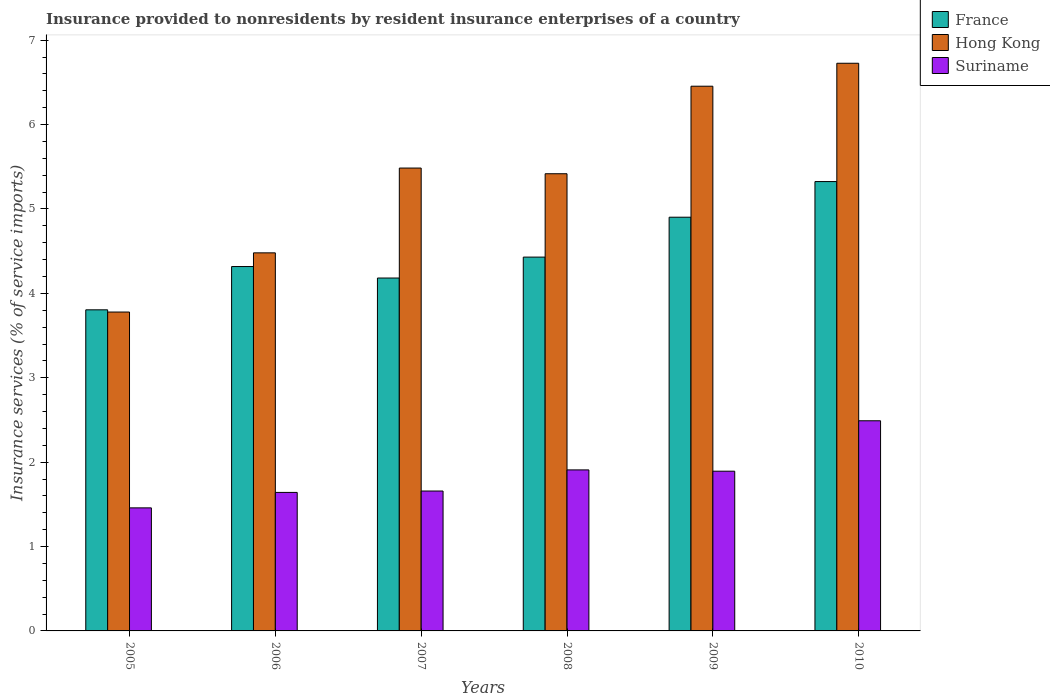How many groups of bars are there?
Ensure brevity in your answer.  6. Are the number of bars per tick equal to the number of legend labels?
Ensure brevity in your answer.  Yes. What is the label of the 2nd group of bars from the left?
Your response must be concise. 2006. In how many cases, is the number of bars for a given year not equal to the number of legend labels?
Offer a very short reply. 0. What is the insurance provided to nonresidents in Suriname in 2009?
Keep it short and to the point. 1.89. Across all years, what is the maximum insurance provided to nonresidents in Suriname?
Provide a succinct answer. 2.49. Across all years, what is the minimum insurance provided to nonresidents in France?
Keep it short and to the point. 3.81. In which year was the insurance provided to nonresidents in Hong Kong minimum?
Ensure brevity in your answer.  2005. What is the total insurance provided to nonresidents in Suriname in the graph?
Your answer should be very brief. 11.05. What is the difference between the insurance provided to nonresidents in Hong Kong in 2005 and that in 2010?
Your answer should be compact. -2.95. What is the difference between the insurance provided to nonresidents in Hong Kong in 2008 and the insurance provided to nonresidents in France in 2009?
Keep it short and to the point. 0.52. What is the average insurance provided to nonresidents in Hong Kong per year?
Your answer should be compact. 5.39. In the year 2006, what is the difference between the insurance provided to nonresidents in Suriname and insurance provided to nonresidents in France?
Your answer should be compact. -2.68. What is the ratio of the insurance provided to nonresidents in Suriname in 2005 to that in 2009?
Give a very brief answer. 0.77. What is the difference between the highest and the second highest insurance provided to nonresidents in France?
Your answer should be very brief. 0.42. What is the difference between the highest and the lowest insurance provided to nonresidents in Hong Kong?
Give a very brief answer. 2.95. Is the sum of the insurance provided to nonresidents in Suriname in 2006 and 2010 greater than the maximum insurance provided to nonresidents in France across all years?
Your answer should be compact. No. What does the 3rd bar from the left in 2007 represents?
Keep it short and to the point. Suriname. What does the 2nd bar from the right in 2006 represents?
Keep it short and to the point. Hong Kong. Is it the case that in every year, the sum of the insurance provided to nonresidents in France and insurance provided to nonresidents in Hong Kong is greater than the insurance provided to nonresidents in Suriname?
Your answer should be compact. Yes. Where does the legend appear in the graph?
Provide a succinct answer. Top right. What is the title of the graph?
Offer a terse response. Insurance provided to nonresidents by resident insurance enterprises of a country. Does "Tanzania" appear as one of the legend labels in the graph?
Offer a very short reply. No. What is the label or title of the X-axis?
Give a very brief answer. Years. What is the label or title of the Y-axis?
Keep it short and to the point. Insurance services (% of service imports). What is the Insurance services (% of service imports) in France in 2005?
Offer a very short reply. 3.81. What is the Insurance services (% of service imports) in Hong Kong in 2005?
Make the answer very short. 3.78. What is the Insurance services (% of service imports) of Suriname in 2005?
Give a very brief answer. 1.46. What is the Insurance services (% of service imports) of France in 2006?
Make the answer very short. 4.32. What is the Insurance services (% of service imports) of Hong Kong in 2006?
Provide a succinct answer. 4.48. What is the Insurance services (% of service imports) of Suriname in 2006?
Offer a terse response. 1.64. What is the Insurance services (% of service imports) of France in 2007?
Your response must be concise. 4.18. What is the Insurance services (% of service imports) of Hong Kong in 2007?
Provide a succinct answer. 5.49. What is the Insurance services (% of service imports) of Suriname in 2007?
Your answer should be compact. 1.66. What is the Insurance services (% of service imports) in France in 2008?
Your answer should be compact. 4.43. What is the Insurance services (% of service imports) of Hong Kong in 2008?
Make the answer very short. 5.42. What is the Insurance services (% of service imports) of Suriname in 2008?
Your answer should be compact. 1.91. What is the Insurance services (% of service imports) in France in 2009?
Your answer should be compact. 4.9. What is the Insurance services (% of service imports) of Hong Kong in 2009?
Provide a short and direct response. 6.45. What is the Insurance services (% of service imports) in Suriname in 2009?
Your response must be concise. 1.89. What is the Insurance services (% of service imports) of France in 2010?
Offer a terse response. 5.32. What is the Insurance services (% of service imports) of Hong Kong in 2010?
Provide a succinct answer. 6.73. What is the Insurance services (% of service imports) in Suriname in 2010?
Provide a succinct answer. 2.49. Across all years, what is the maximum Insurance services (% of service imports) of France?
Provide a succinct answer. 5.32. Across all years, what is the maximum Insurance services (% of service imports) of Hong Kong?
Offer a very short reply. 6.73. Across all years, what is the maximum Insurance services (% of service imports) of Suriname?
Make the answer very short. 2.49. Across all years, what is the minimum Insurance services (% of service imports) in France?
Ensure brevity in your answer.  3.81. Across all years, what is the minimum Insurance services (% of service imports) in Hong Kong?
Ensure brevity in your answer.  3.78. Across all years, what is the minimum Insurance services (% of service imports) in Suriname?
Your answer should be very brief. 1.46. What is the total Insurance services (% of service imports) in France in the graph?
Your answer should be very brief. 26.96. What is the total Insurance services (% of service imports) in Hong Kong in the graph?
Offer a terse response. 32.34. What is the total Insurance services (% of service imports) in Suriname in the graph?
Provide a succinct answer. 11.05. What is the difference between the Insurance services (% of service imports) in France in 2005 and that in 2006?
Make the answer very short. -0.51. What is the difference between the Insurance services (% of service imports) in Hong Kong in 2005 and that in 2006?
Provide a short and direct response. -0.7. What is the difference between the Insurance services (% of service imports) of Suriname in 2005 and that in 2006?
Your response must be concise. -0.18. What is the difference between the Insurance services (% of service imports) in France in 2005 and that in 2007?
Give a very brief answer. -0.38. What is the difference between the Insurance services (% of service imports) in Hong Kong in 2005 and that in 2007?
Keep it short and to the point. -1.71. What is the difference between the Insurance services (% of service imports) of Suriname in 2005 and that in 2007?
Make the answer very short. -0.2. What is the difference between the Insurance services (% of service imports) in France in 2005 and that in 2008?
Your answer should be very brief. -0.62. What is the difference between the Insurance services (% of service imports) of Hong Kong in 2005 and that in 2008?
Provide a succinct answer. -1.64. What is the difference between the Insurance services (% of service imports) of Suriname in 2005 and that in 2008?
Keep it short and to the point. -0.45. What is the difference between the Insurance services (% of service imports) of France in 2005 and that in 2009?
Your response must be concise. -1.1. What is the difference between the Insurance services (% of service imports) of Hong Kong in 2005 and that in 2009?
Your response must be concise. -2.68. What is the difference between the Insurance services (% of service imports) in Suriname in 2005 and that in 2009?
Give a very brief answer. -0.43. What is the difference between the Insurance services (% of service imports) in France in 2005 and that in 2010?
Offer a very short reply. -1.52. What is the difference between the Insurance services (% of service imports) of Hong Kong in 2005 and that in 2010?
Your answer should be compact. -2.95. What is the difference between the Insurance services (% of service imports) in Suriname in 2005 and that in 2010?
Your answer should be very brief. -1.03. What is the difference between the Insurance services (% of service imports) of France in 2006 and that in 2007?
Your answer should be compact. 0.14. What is the difference between the Insurance services (% of service imports) of Hong Kong in 2006 and that in 2007?
Your response must be concise. -1. What is the difference between the Insurance services (% of service imports) in Suriname in 2006 and that in 2007?
Ensure brevity in your answer.  -0.02. What is the difference between the Insurance services (% of service imports) of France in 2006 and that in 2008?
Make the answer very short. -0.11. What is the difference between the Insurance services (% of service imports) of Hong Kong in 2006 and that in 2008?
Keep it short and to the point. -0.94. What is the difference between the Insurance services (% of service imports) in Suriname in 2006 and that in 2008?
Offer a terse response. -0.27. What is the difference between the Insurance services (% of service imports) in France in 2006 and that in 2009?
Make the answer very short. -0.58. What is the difference between the Insurance services (% of service imports) of Hong Kong in 2006 and that in 2009?
Your answer should be compact. -1.97. What is the difference between the Insurance services (% of service imports) in Suriname in 2006 and that in 2009?
Offer a very short reply. -0.25. What is the difference between the Insurance services (% of service imports) of France in 2006 and that in 2010?
Keep it short and to the point. -1.01. What is the difference between the Insurance services (% of service imports) of Hong Kong in 2006 and that in 2010?
Your response must be concise. -2.25. What is the difference between the Insurance services (% of service imports) of Suriname in 2006 and that in 2010?
Offer a very short reply. -0.85. What is the difference between the Insurance services (% of service imports) of France in 2007 and that in 2008?
Provide a short and direct response. -0.25. What is the difference between the Insurance services (% of service imports) in Hong Kong in 2007 and that in 2008?
Provide a short and direct response. 0.07. What is the difference between the Insurance services (% of service imports) of Suriname in 2007 and that in 2008?
Provide a succinct answer. -0.25. What is the difference between the Insurance services (% of service imports) of France in 2007 and that in 2009?
Provide a succinct answer. -0.72. What is the difference between the Insurance services (% of service imports) in Hong Kong in 2007 and that in 2009?
Your response must be concise. -0.97. What is the difference between the Insurance services (% of service imports) of Suriname in 2007 and that in 2009?
Provide a succinct answer. -0.23. What is the difference between the Insurance services (% of service imports) in France in 2007 and that in 2010?
Your answer should be compact. -1.14. What is the difference between the Insurance services (% of service imports) in Hong Kong in 2007 and that in 2010?
Provide a short and direct response. -1.24. What is the difference between the Insurance services (% of service imports) in Suriname in 2007 and that in 2010?
Provide a short and direct response. -0.83. What is the difference between the Insurance services (% of service imports) of France in 2008 and that in 2009?
Your response must be concise. -0.47. What is the difference between the Insurance services (% of service imports) in Hong Kong in 2008 and that in 2009?
Your answer should be very brief. -1.04. What is the difference between the Insurance services (% of service imports) in Suriname in 2008 and that in 2009?
Provide a short and direct response. 0.02. What is the difference between the Insurance services (% of service imports) of France in 2008 and that in 2010?
Ensure brevity in your answer.  -0.9. What is the difference between the Insurance services (% of service imports) of Hong Kong in 2008 and that in 2010?
Provide a succinct answer. -1.31. What is the difference between the Insurance services (% of service imports) in Suriname in 2008 and that in 2010?
Make the answer very short. -0.58. What is the difference between the Insurance services (% of service imports) of France in 2009 and that in 2010?
Offer a terse response. -0.42. What is the difference between the Insurance services (% of service imports) in Hong Kong in 2009 and that in 2010?
Offer a very short reply. -0.27. What is the difference between the Insurance services (% of service imports) in Suriname in 2009 and that in 2010?
Offer a terse response. -0.6. What is the difference between the Insurance services (% of service imports) in France in 2005 and the Insurance services (% of service imports) in Hong Kong in 2006?
Give a very brief answer. -0.68. What is the difference between the Insurance services (% of service imports) in France in 2005 and the Insurance services (% of service imports) in Suriname in 2006?
Make the answer very short. 2.16. What is the difference between the Insurance services (% of service imports) in Hong Kong in 2005 and the Insurance services (% of service imports) in Suriname in 2006?
Offer a terse response. 2.14. What is the difference between the Insurance services (% of service imports) of France in 2005 and the Insurance services (% of service imports) of Hong Kong in 2007?
Give a very brief answer. -1.68. What is the difference between the Insurance services (% of service imports) in France in 2005 and the Insurance services (% of service imports) in Suriname in 2007?
Provide a short and direct response. 2.15. What is the difference between the Insurance services (% of service imports) of Hong Kong in 2005 and the Insurance services (% of service imports) of Suriname in 2007?
Your response must be concise. 2.12. What is the difference between the Insurance services (% of service imports) of France in 2005 and the Insurance services (% of service imports) of Hong Kong in 2008?
Provide a short and direct response. -1.61. What is the difference between the Insurance services (% of service imports) of France in 2005 and the Insurance services (% of service imports) of Suriname in 2008?
Offer a terse response. 1.9. What is the difference between the Insurance services (% of service imports) in Hong Kong in 2005 and the Insurance services (% of service imports) in Suriname in 2008?
Your response must be concise. 1.87. What is the difference between the Insurance services (% of service imports) of France in 2005 and the Insurance services (% of service imports) of Hong Kong in 2009?
Your response must be concise. -2.65. What is the difference between the Insurance services (% of service imports) of France in 2005 and the Insurance services (% of service imports) of Suriname in 2009?
Ensure brevity in your answer.  1.91. What is the difference between the Insurance services (% of service imports) in Hong Kong in 2005 and the Insurance services (% of service imports) in Suriname in 2009?
Make the answer very short. 1.89. What is the difference between the Insurance services (% of service imports) in France in 2005 and the Insurance services (% of service imports) in Hong Kong in 2010?
Ensure brevity in your answer.  -2.92. What is the difference between the Insurance services (% of service imports) of France in 2005 and the Insurance services (% of service imports) of Suriname in 2010?
Your answer should be very brief. 1.31. What is the difference between the Insurance services (% of service imports) of Hong Kong in 2005 and the Insurance services (% of service imports) of Suriname in 2010?
Offer a very short reply. 1.29. What is the difference between the Insurance services (% of service imports) in France in 2006 and the Insurance services (% of service imports) in Hong Kong in 2007?
Provide a short and direct response. -1.17. What is the difference between the Insurance services (% of service imports) in France in 2006 and the Insurance services (% of service imports) in Suriname in 2007?
Provide a short and direct response. 2.66. What is the difference between the Insurance services (% of service imports) in Hong Kong in 2006 and the Insurance services (% of service imports) in Suriname in 2007?
Your response must be concise. 2.82. What is the difference between the Insurance services (% of service imports) of France in 2006 and the Insurance services (% of service imports) of Hong Kong in 2008?
Provide a short and direct response. -1.1. What is the difference between the Insurance services (% of service imports) of France in 2006 and the Insurance services (% of service imports) of Suriname in 2008?
Make the answer very short. 2.41. What is the difference between the Insurance services (% of service imports) of Hong Kong in 2006 and the Insurance services (% of service imports) of Suriname in 2008?
Offer a terse response. 2.57. What is the difference between the Insurance services (% of service imports) of France in 2006 and the Insurance services (% of service imports) of Hong Kong in 2009?
Your answer should be very brief. -2.14. What is the difference between the Insurance services (% of service imports) in France in 2006 and the Insurance services (% of service imports) in Suriname in 2009?
Provide a succinct answer. 2.43. What is the difference between the Insurance services (% of service imports) in Hong Kong in 2006 and the Insurance services (% of service imports) in Suriname in 2009?
Give a very brief answer. 2.59. What is the difference between the Insurance services (% of service imports) in France in 2006 and the Insurance services (% of service imports) in Hong Kong in 2010?
Ensure brevity in your answer.  -2.41. What is the difference between the Insurance services (% of service imports) of France in 2006 and the Insurance services (% of service imports) of Suriname in 2010?
Ensure brevity in your answer.  1.83. What is the difference between the Insurance services (% of service imports) of Hong Kong in 2006 and the Insurance services (% of service imports) of Suriname in 2010?
Give a very brief answer. 1.99. What is the difference between the Insurance services (% of service imports) of France in 2007 and the Insurance services (% of service imports) of Hong Kong in 2008?
Your answer should be very brief. -1.24. What is the difference between the Insurance services (% of service imports) of France in 2007 and the Insurance services (% of service imports) of Suriname in 2008?
Your answer should be very brief. 2.27. What is the difference between the Insurance services (% of service imports) in Hong Kong in 2007 and the Insurance services (% of service imports) in Suriname in 2008?
Provide a succinct answer. 3.58. What is the difference between the Insurance services (% of service imports) in France in 2007 and the Insurance services (% of service imports) in Hong Kong in 2009?
Make the answer very short. -2.27. What is the difference between the Insurance services (% of service imports) of France in 2007 and the Insurance services (% of service imports) of Suriname in 2009?
Ensure brevity in your answer.  2.29. What is the difference between the Insurance services (% of service imports) of Hong Kong in 2007 and the Insurance services (% of service imports) of Suriname in 2009?
Make the answer very short. 3.59. What is the difference between the Insurance services (% of service imports) in France in 2007 and the Insurance services (% of service imports) in Hong Kong in 2010?
Your answer should be compact. -2.55. What is the difference between the Insurance services (% of service imports) in France in 2007 and the Insurance services (% of service imports) in Suriname in 2010?
Your answer should be compact. 1.69. What is the difference between the Insurance services (% of service imports) in Hong Kong in 2007 and the Insurance services (% of service imports) in Suriname in 2010?
Provide a succinct answer. 2.99. What is the difference between the Insurance services (% of service imports) in France in 2008 and the Insurance services (% of service imports) in Hong Kong in 2009?
Your answer should be very brief. -2.03. What is the difference between the Insurance services (% of service imports) in France in 2008 and the Insurance services (% of service imports) in Suriname in 2009?
Your answer should be compact. 2.54. What is the difference between the Insurance services (% of service imports) of Hong Kong in 2008 and the Insurance services (% of service imports) of Suriname in 2009?
Make the answer very short. 3.52. What is the difference between the Insurance services (% of service imports) of France in 2008 and the Insurance services (% of service imports) of Hong Kong in 2010?
Give a very brief answer. -2.3. What is the difference between the Insurance services (% of service imports) of France in 2008 and the Insurance services (% of service imports) of Suriname in 2010?
Provide a succinct answer. 1.94. What is the difference between the Insurance services (% of service imports) of Hong Kong in 2008 and the Insurance services (% of service imports) of Suriname in 2010?
Provide a short and direct response. 2.93. What is the difference between the Insurance services (% of service imports) in France in 2009 and the Insurance services (% of service imports) in Hong Kong in 2010?
Offer a terse response. -1.82. What is the difference between the Insurance services (% of service imports) in France in 2009 and the Insurance services (% of service imports) in Suriname in 2010?
Offer a very short reply. 2.41. What is the difference between the Insurance services (% of service imports) in Hong Kong in 2009 and the Insurance services (% of service imports) in Suriname in 2010?
Keep it short and to the point. 3.96. What is the average Insurance services (% of service imports) in France per year?
Give a very brief answer. 4.49. What is the average Insurance services (% of service imports) of Hong Kong per year?
Your answer should be compact. 5.39. What is the average Insurance services (% of service imports) of Suriname per year?
Your response must be concise. 1.84. In the year 2005, what is the difference between the Insurance services (% of service imports) in France and Insurance services (% of service imports) in Hong Kong?
Ensure brevity in your answer.  0.03. In the year 2005, what is the difference between the Insurance services (% of service imports) in France and Insurance services (% of service imports) in Suriname?
Your answer should be very brief. 2.35. In the year 2005, what is the difference between the Insurance services (% of service imports) of Hong Kong and Insurance services (% of service imports) of Suriname?
Your answer should be very brief. 2.32. In the year 2006, what is the difference between the Insurance services (% of service imports) of France and Insurance services (% of service imports) of Hong Kong?
Give a very brief answer. -0.16. In the year 2006, what is the difference between the Insurance services (% of service imports) of France and Insurance services (% of service imports) of Suriname?
Provide a succinct answer. 2.68. In the year 2006, what is the difference between the Insurance services (% of service imports) of Hong Kong and Insurance services (% of service imports) of Suriname?
Your response must be concise. 2.84. In the year 2007, what is the difference between the Insurance services (% of service imports) in France and Insurance services (% of service imports) in Hong Kong?
Your answer should be very brief. -1.3. In the year 2007, what is the difference between the Insurance services (% of service imports) of France and Insurance services (% of service imports) of Suriname?
Your answer should be compact. 2.52. In the year 2007, what is the difference between the Insurance services (% of service imports) of Hong Kong and Insurance services (% of service imports) of Suriname?
Ensure brevity in your answer.  3.83. In the year 2008, what is the difference between the Insurance services (% of service imports) of France and Insurance services (% of service imports) of Hong Kong?
Keep it short and to the point. -0.99. In the year 2008, what is the difference between the Insurance services (% of service imports) of France and Insurance services (% of service imports) of Suriname?
Provide a short and direct response. 2.52. In the year 2008, what is the difference between the Insurance services (% of service imports) in Hong Kong and Insurance services (% of service imports) in Suriname?
Provide a succinct answer. 3.51. In the year 2009, what is the difference between the Insurance services (% of service imports) of France and Insurance services (% of service imports) of Hong Kong?
Provide a short and direct response. -1.55. In the year 2009, what is the difference between the Insurance services (% of service imports) in France and Insurance services (% of service imports) in Suriname?
Ensure brevity in your answer.  3.01. In the year 2009, what is the difference between the Insurance services (% of service imports) of Hong Kong and Insurance services (% of service imports) of Suriname?
Provide a succinct answer. 4.56. In the year 2010, what is the difference between the Insurance services (% of service imports) in France and Insurance services (% of service imports) in Hong Kong?
Ensure brevity in your answer.  -1.4. In the year 2010, what is the difference between the Insurance services (% of service imports) in France and Insurance services (% of service imports) in Suriname?
Your answer should be very brief. 2.83. In the year 2010, what is the difference between the Insurance services (% of service imports) in Hong Kong and Insurance services (% of service imports) in Suriname?
Make the answer very short. 4.24. What is the ratio of the Insurance services (% of service imports) in France in 2005 to that in 2006?
Make the answer very short. 0.88. What is the ratio of the Insurance services (% of service imports) of Hong Kong in 2005 to that in 2006?
Your response must be concise. 0.84. What is the ratio of the Insurance services (% of service imports) of Suriname in 2005 to that in 2006?
Your response must be concise. 0.89. What is the ratio of the Insurance services (% of service imports) in France in 2005 to that in 2007?
Offer a terse response. 0.91. What is the ratio of the Insurance services (% of service imports) of Hong Kong in 2005 to that in 2007?
Offer a terse response. 0.69. What is the ratio of the Insurance services (% of service imports) in Suriname in 2005 to that in 2007?
Your answer should be very brief. 0.88. What is the ratio of the Insurance services (% of service imports) of France in 2005 to that in 2008?
Ensure brevity in your answer.  0.86. What is the ratio of the Insurance services (% of service imports) of Hong Kong in 2005 to that in 2008?
Provide a succinct answer. 0.7. What is the ratio of the Insurance services (% of service imports) of Suriname in 2005 to that in 2008?
Keep it short and to the point. 0.76. What is the ratio of the Insurance services (% of service imports) of France in 2005 to that in 2009?
Ensure brevity in your answer.  0.78. What is the ratio of the Insurance services (% of service imports) in Hong Kong in 2005 to that in 2009?
Provide a short and direct response. 0.59. What is the ratio of the Insurance services (% of service imports) of Suriname in 2005 to that in 2009?
Make the answer very short. 0.77. What is the ratio of the Insurance services (% of service imports) of France in 2005 to that in 2010?
Your response must be concise. 0.71. What is the ratio of the Insurance services (% of service imports) in Hong Kong in 2005 to that in 2010?
Your response must be concise. 0.56. What is the ratio of the Insurance services (% of service imports) of Suriname in 2005 to that in 2010?
Offer a terse response. 0.59. What is the ratio of the Insurance services (% of service imports) of France in 2006 to that in 2007?
Offer a terse response. 1.03. What is the ratio of the Insurance services (% of service imports) in Hong Kong in 2006 to that in 2007?
Your response must be concise. 0.82. What is the ratio of the Insurance services (% of service imports) in Suriname in 2006 to that in 2007?
Provide a succinct answer. 0.99. What is the ratio of the Insurance services (% of service imports) in France in 2006 to that in 2008?
Offer a terse response. 0.97. What is the ratio of the Insurance services (% of service imports) of Hong Kong in 2006 to that in 2008?
Keep it short and to the point. 0.83. What is the ratio of the Insurance services (% of service imports) of Suriname in 2006 to that in 2008?
Offer a terse response. 0.86. What is the ratio of the Insurance services (% of service imports) in France in 2006 to that in 2009?
Offer a terse response. 0.88. What is the ratio of the Insurance services (% of service imports) of Hong Kong in 2006 to that in 2009?
Give a very brief answer. 0.69. What is the ratio of the Insurance services (% of service imports) in Suriname in 2006 to that in 2009?
Your answer should be very brief. 0.87. What is the ratio of the Insurance services (% of service imports) in France in 2006 to that in 2010?
Your answer should be very brief. 0.81. What is the ratio of the Insurance services (% of service imports) in Hong Kong in 2006 to that in 2010?
Make the answer very short. 0.67. What is the ratio of the Insurance services (% of service imports) of Suriname in 2006 to that in 2010?
Make the answer very short. 0.66. What is the ratio of the Insurance services (% of service imports) of France in 2007 to that in 2008?
Offer a terse response. 0.94. What is the ratio of the Insurance services (% of service imports) of Hong Kong in 2007 to that in 2008?
Offer a terse response. 1.01. What is the ratio of the Insurance services (% of service imports) in Suriname in 2007 to that in 2008?
Your response must be concise. 0.87. What is the ratio of the Insurance services (% of service imports) of France in 2007 to that in 2009?
Keep it short and to the point. 0.85. What is the ratio of the Insurance services (% of service imports) in Hong Kong in 2007 to that in 2009?
Make the answer very short. 0.85. What is the ratio of the Insurance services (% of service imports) in Suriname in 2007 to that in 2009?
Provide a short and direct response. 0.88. What is the ratio of the Insurance services (% of service imports) in France in 2007 to that in 2010?
Provide a succinct answer. 0.79. What is the ratio of the Insurance services (% of service imports) of Hong Kong in 2007 to that in 2010?
Your answer should be very brief. 0.82. What is the ratio of the Insurance services (% of service imports) in Suriname in 2007 to that in 2010?
Give a very brief answer. 0.67. What is the ratio of the Insurance services (% of service imports) in France in 2008 to that in 2009?
Give a very brief answer. 0.9. What is the ratio of the Insurance services (% of service imports) of Hong Kong in 2008 to that in 2009?
Provide a short and direct response. 0.84. What is the ratio of the Insurance services (% of service imports) in France in 2008 to that in 2010?
Your answer should be very brief. 0.83. What is the ratio of the Insurance services (% of service imports) of Hong Kong in 2008 to that in 2010?
Ensure brevity in your answer.  0.81. What is the ratio of the Insurance services (% of service imports) of Suriname in 2008 to that in 2010?
Your response must be concise. 0.77. What is the ratio of the Insurance services (% of service imports) in France in 2009 to that in 2010?
Provide a succinct answer. 0.92. What is the ratio of the Insurance services (% of service imports) of Hong Kong in 2009 to that in 2010?
Keep it short and to the point. 0.96. What is the ratio of the Insurance services (% of service imports) of Suriname in 2009 to that in 2010?
Your response must be concise. 0.76. What is the difference between the highest and the second highest Insurance services (% of service imports) in France?
Your answer should be very brief. 0.42. What is the difference between the highest and the second highest Insurance services (% of service imports) in Hong Kong?
Offer a terse response. 0.27. What is the difference between the highest and the second highest Insurance services (% of service imports) of Suriname?
Offer a very short reply. 0.58. What is the difference between the highest and the lowest Insurance services (% of service imports) in France?
Give a very brief answer. 1.52. What is the difference between the highest and the lowest Insurance services (% of service imports) of Hong Kong?
Ensure brevity in your answer.  2.95. What is the difference between the highest and the lowest Insurance services (% of service imports) in Suriname?
Your response must be concise. 1.03. 